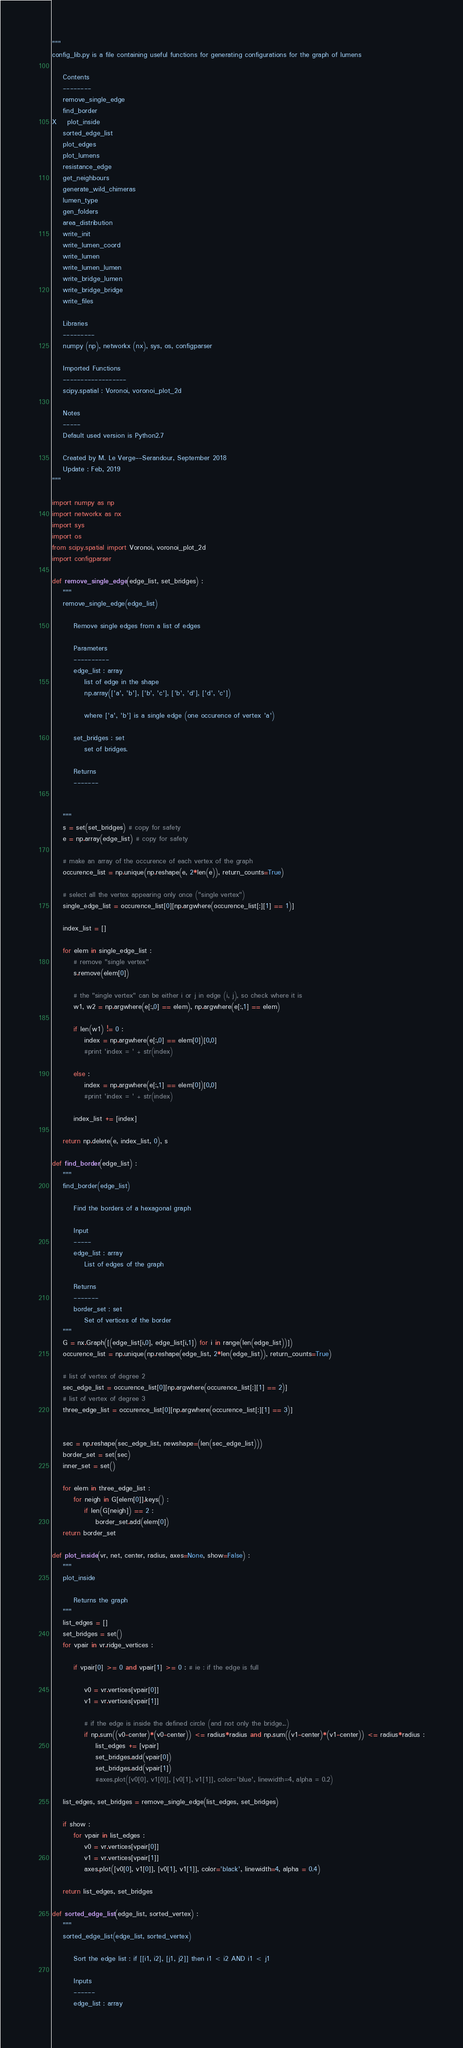Convert code to text. <code><loc_0><loc_0><loc_500><loc_500><_Python_>"""
config_lib.py is a file containing useful functions for generating configurations for the graph of lumens

    Contents
    --------
    remove_single_edge
    find_border
X    plot_inside
    sorted_edge_list
    plot_edges
    plot_lumens
    resistance_edge
    get_neighbours
    generate_wild_chimeras
    lumen_type
    gen_folders
    area_distribution
    write_init
    write_lumen_coord
    write_lumen
    write_lumen_lumen
    write_bridge_lumen
    write_bridge_bridge
    write_files

    Libraries
    ---------
    numpy (np), networkx (nx), sys, os, configparser
    
    Imported Functions
    ------------------
    scipy.spatial : Voronoi, voronoi_plot_2d

    Notes
    -----
    Default used version is Python2.7

    Created by M. Le Verge--Serandour, September 2018
    Update : Feb, 2019
"""

import numpy as np
import networkx as nx
import sys
import os
from scipy.spatial import Voronoi, voronoi_plot_2d
import configparser
	
def remove_single_edge(edge_list, set_bridges) :
    """
    remove_single_edge(edge_list)
    
        Remove single edges from a list of edges
        
        Parameters
        ----------
        edge_list : array
            list of edge in the shape 
            np.array(['a', 'b'], ['b', 'c'], ['b', 'd'], ['d', 'c'])
            
            where ['a', 'b'] is a single edge (one occurence of vertex 'a')
            
        set_bridges : set
            set of bridges.
        
        Returns
        -------
        
        
    """
    s = set(set_bridges) # copy for safety
    e = np.array(edge_list) # copy for safety
    
    # make an array of the occurence of each vertex of the graph
    occurence_list = np.unique(np.reshape(e, 2*len(e)), return_counts=True)
    
    # select all the vertex appearing only once ("single vertex")
    single_edge_list = occurence_list[0][np.argwhere(occurence_list[:][1] == 1)]
    
    index_list = []
    
    for elem in single_edge_list :
        # remove "single vertex"
        s.remove(elem[0])
        
        # the "single vertex" can be either i or j in edge (i, j), so check where it is
        w1, w2 = np.argwhere(e[:,0] == elem), np.argwhere(e[:,1] == elem)

        if len(w1) != 0 :
            index = np.argwhere(e[:,0] == elem[0])[0,0]
            #print 'index = ' + str(index)
        
        else :
            index = np.argwhere(e[:,1] == elem[0])[0,0]
            #print 'index = ' + str(index)
        
        index_list += [index]
    
    return np.delete(e, index_list, 0), s

def find_border(edge_list) :
    """
    find_border(edge_list)
    
        Find the borders of a hexagonal graph
    
        Input
        -----
        edge_list : array
            List of edges of the graph
    
        Returns
        -------
        border_set : set
            Set of vertices of the border
    """
    G = nx.Graph([(edge_list[i,0], edge_list[i,1]) for i in range(len(edge_list))])
    occurence_list = np.unique(np.reshape(edge_list, 2*len(edge_list)), return_counts=True)
    
    # list of vertex of degree 2
    sec_edge_list = occurence_list[0][np.argwhere(occurence_list[:][1] == 2)]
    # list of vertex of degree 3
    three_edge_list = occurence_list[0][np.argwhere(occurence_list[:][1] == 3)]


    sec = np.reshape(sec_edge_list, newshape=(len(sec_edge_list)))
    border_set = set(sec)
    inner_set = set()

    for elem in three_edge_list :
        for neigh in G[elem[0]].keys() :
            if len(G[neigh]) == 2 :
                border_set.add(elem[0])
    return border_set

def plot_inside(vr, net, center, radius, axes=None, show=False) :
    """
    plot_inside
    
        Returns the graph
    """
    list_edges = []
    set_bridges = set()
    for vpair in vr.ridge_vertices :
        
        if vpair[0] >= 0 and vpair[1] >= 0 : # ie : if the edge is full            
                
            v0 = vr.vertices[vpair[0]]
            v1 = vr.vertices[vpair[1]]
            
            # if the edge is inside the defined circle (and not only the bridge...)
            if np.sum((v0-center)*(v0-center)) <= radius*radius and np.sum((v1-center)*(v1-center)) <= radius*radius :
                list_edges += [vpair]
                set_bridges.add(vpair[0])
                set_bridges.add(vpair[1])
                #axes.plot([v0[0], v1[0]], [v0[1], v1[1]], color='blue', linewidth=4, alpha = 0.2)
    
    list_edges, set_bridges = remove_single_edge(list_edges, set_bridges)
    
    if show :
        for vpair in list_edges :
            v0 = vr.vertices[vpair[0]]
            v1 = vr.vertices[vpair[1]]
            axes.plot([v0[0], v1[0]], [v0[1], v1[1]], color='black', linewidth=4, alpha = 0.4)
    
    return list_edges, set_bridges

def sorted_edge_list(edge_list, sorted_vertex) :
    """
    sorted_edge_list(edge_list, sorted_vertex)
    
        Sort the edge list : if [[i1, i2], [j1, j2]] then i1 < i2 AND i1 < j1
    
        Inputs
        ------
        edge_list : array</code> 